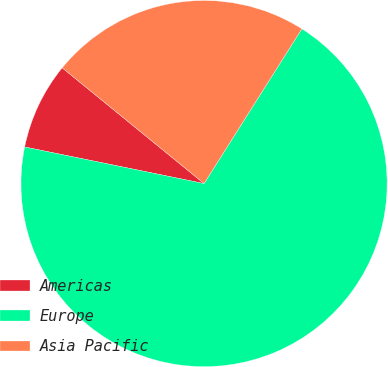Convert chart to OTSL. <chart><loc_0><loc_0><loc_500><loc_500><pie_chart><fcel>Americas<fcel>Europe<fcel>Asia Pacific<nl><fcel>7.69%<fcel>69.23%<fcel>23.08%<nl></chart> 